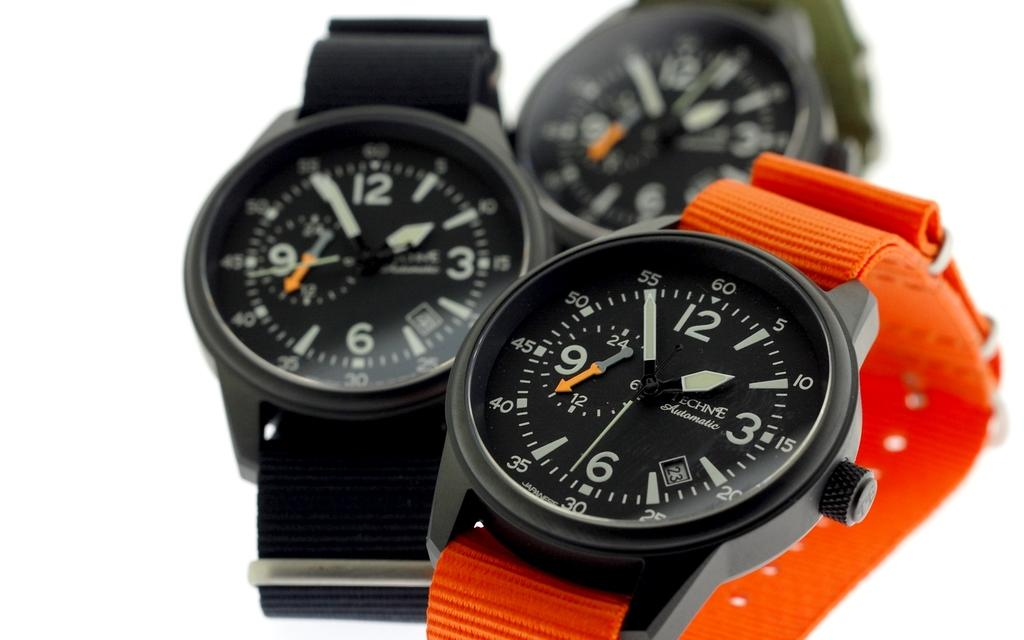What objects are featured in the image? There are watches in the image. What color is the background of the image? The background of the image is white. Can you hear the sound of the sea in the image? There is no sound or reference to the sea in the image, so it cannot be heard. 